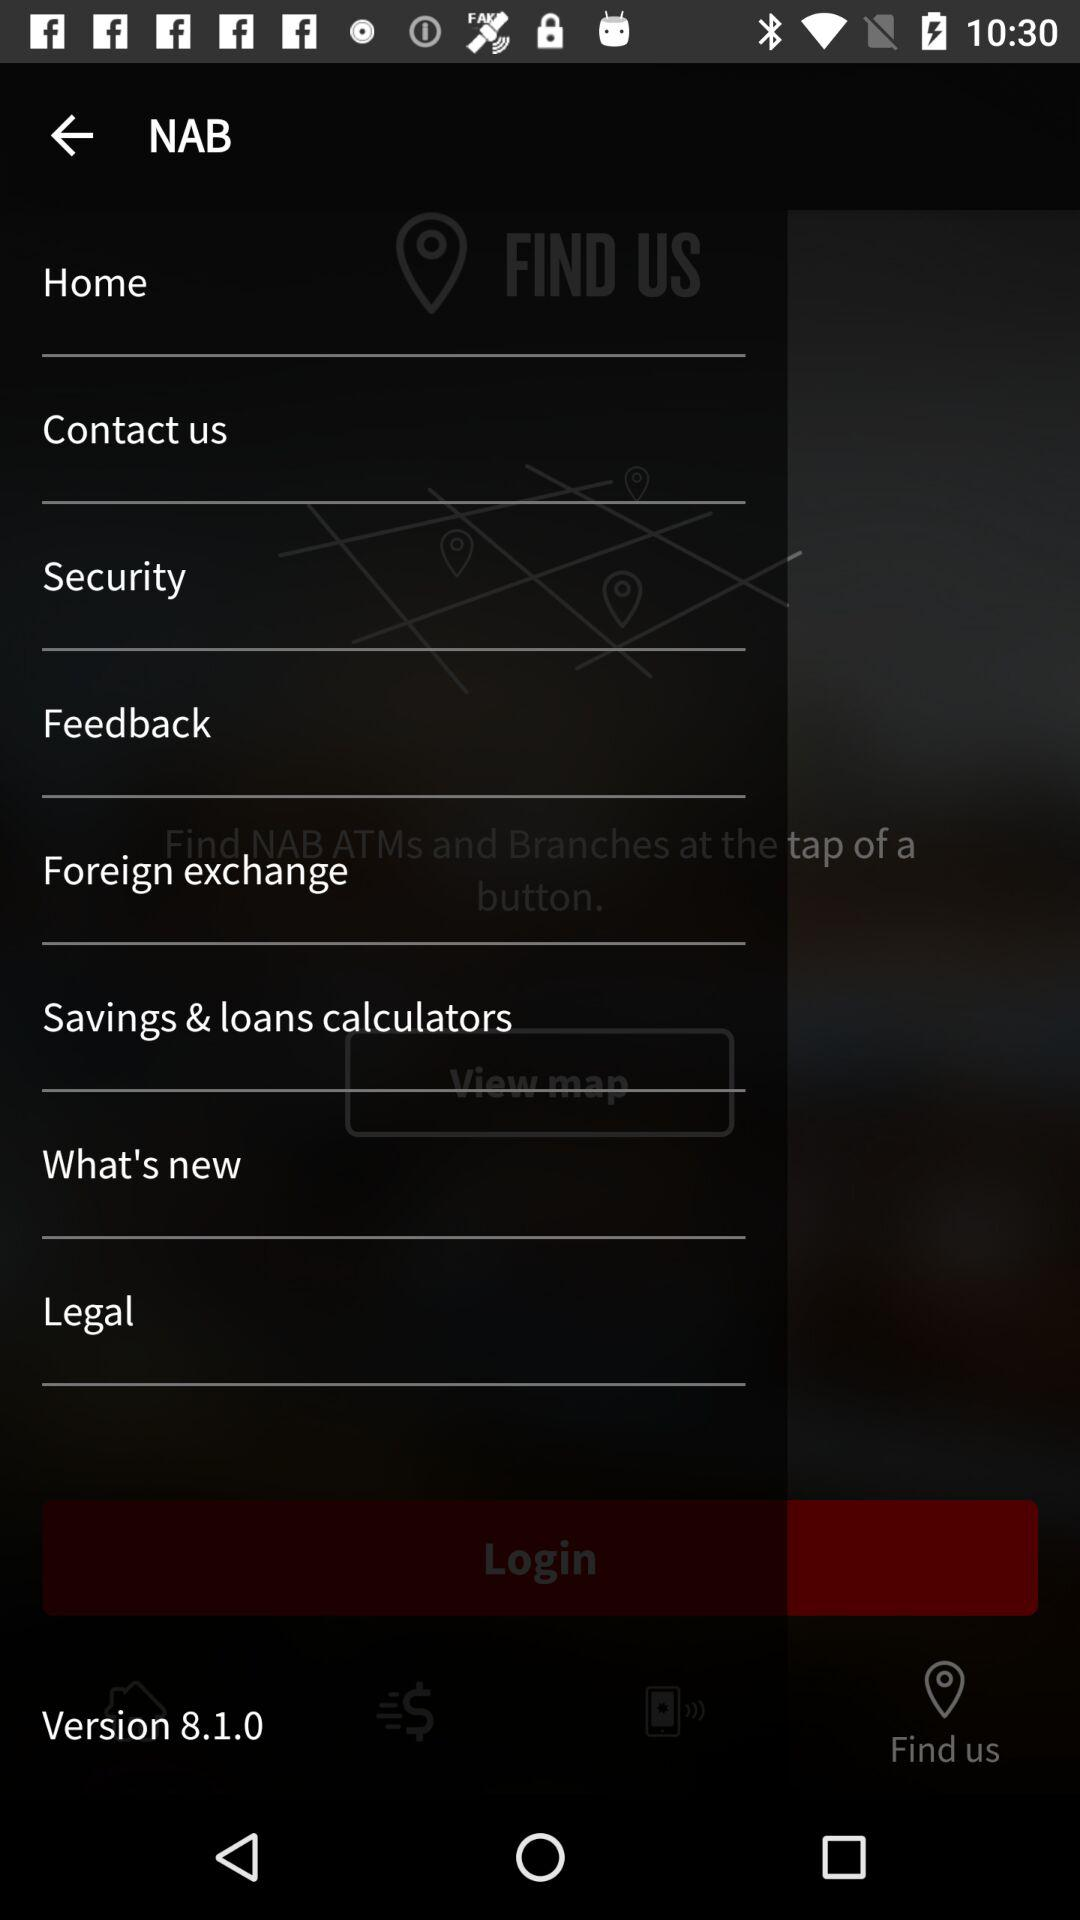What is the app name? The app name is "NAB". 